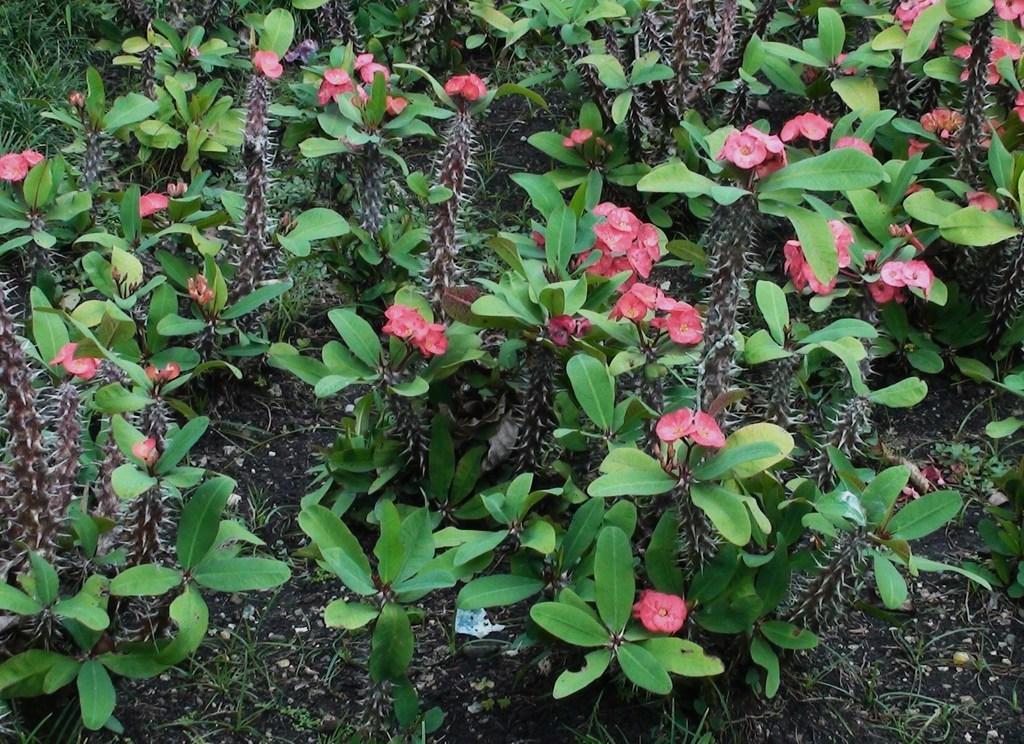In one or two sentences, can you explain what this image depicts? These are the plants with leaves and flowers. These plants are named as the crown-of-thorns. 